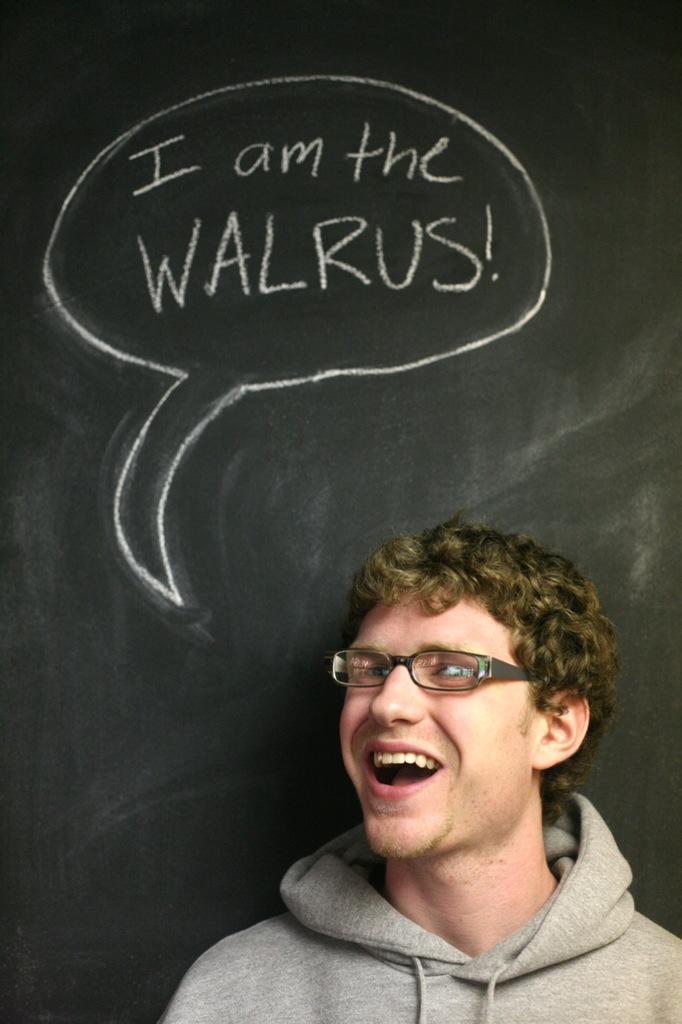Can you describe this image briefly? In this image I can see a person wearing a gray color jacket and wearing a spectacle ,he is smiling standing in front of the black color board, on the board I can see text. 